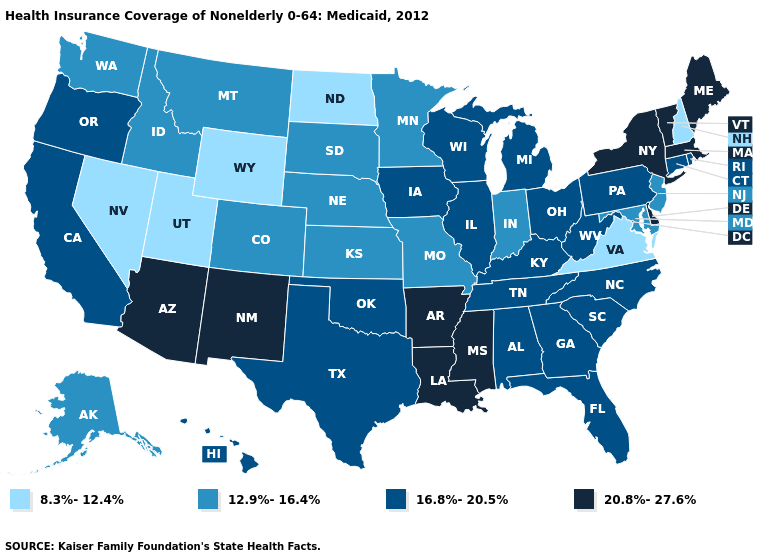What is the value of Washington?
Give a very brief answer. 12.9%-16.4%. How many symbols are there in the legend?
Write a very short answer. 4. Name the states that have a value in the range 8.3%-12.4%?
Short answer required. Nevada, New Hampshire, North Dakota, Utah, Virginia, Wyoming. What is the value of Hawaii?
Give a very brief answer. 16.8%-20.5%. Is the legend a continuous bar?
Answer briefly. No. How many symbols are there in the legend?
Keep it brief. 4. Name the states that have a value in the range 12.9%-16.4%?
Give a very brief answer. Alaska, Colorado, Idaho, Indiana, Kansas, Maryland, Minnesota, Missouri, Montana, Nebraska, New Jersey, South Dakota, Washington. Does Minnesota have the highest value in the MidWest?
Quick response, please. No. Name the states that have a value in the range 12.9%-16.4%?
Short answer required. Alaska, Colorado, Idaho, Indiana, Kansas, Maryland, Minnesota, Missouri, Montana, Nebraska, New Jersey, South Dakota, Washington. Among the states that border Alabama , does Florida have the lowest value?
Short answer required. Yes. What is the value of Kansas?
Short answer required. 12.9%-16.4%. Does the first symbol in the legend represent the smallest category?
Write a very short answer. Yes. What is the highest value in the USA?
Short answer required. 20.8%-27.6%. Name the states that have a value in the range 20.8%-27.6%?
Give a very brief answer. Arizona, Arkansas, Delaware, Louisiana, Maine, Massachusetts, Mississippi, New Mexico, New York, Vermont. Does Maine have the lowest value in the Northeast?
Give a very brief answer. No. 